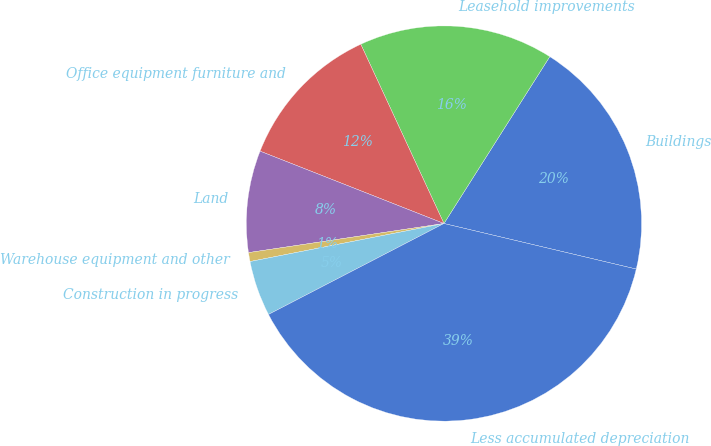Convert chart to OTSL. <chart><loc_0><loc_0><loc_500><loc_500><pie_chart><fcel>Buildings<fcel>Leasehold improvements<fcel>Office equipment furniture and<fcel>Land<fcel>Warehouse equipment and other<fcel>Construction in progress<fcel>Less accumulated depreciation<nl><fcel>19.71%<fcel>15.91%<fcel>12.12%<fcel>8.32%<fcel>0.73%<fcel>4.53%<fcel>38.69%<nl></chart> 